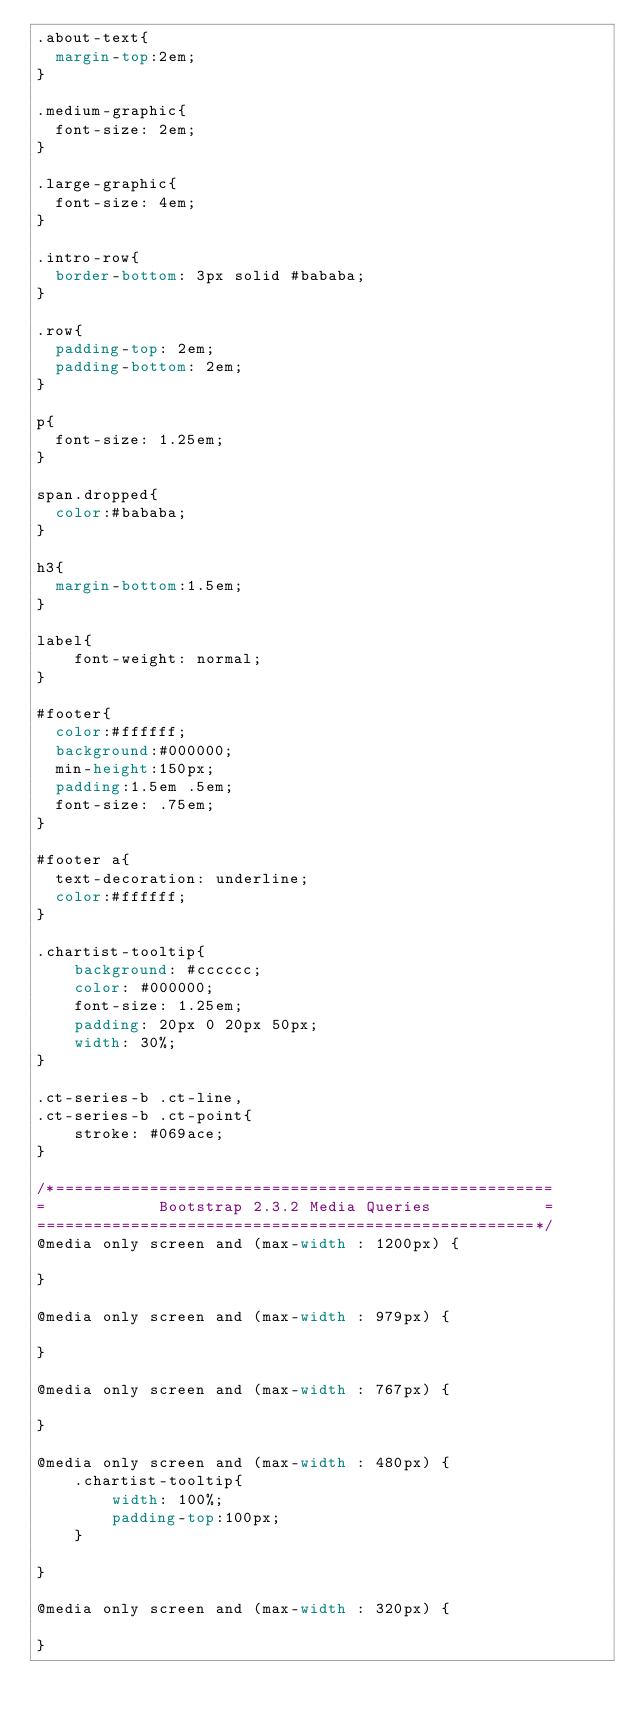<code> <loc_0><loc_0><loc_500><loc_500><_CSS_>.about-text{
  margin-top:2em;
}

.medium-graphic{
  font-size: 2em;
}

.large-graphic{
  font-size: 4em;
}

.intro-row{
  border-bottom: 3px solid #bababa;
}

.row{
  padding-top: 2em;
  padding-bottom: 2em;
}

p{
  font-size: 1.25em;
}

span.dropped{
  color:#bababa;
}

h3{
  margin-bottom:1.5em;
}

label{
    font-weight: normal;
}

#footer{
  color:#ffffff;
  background:#000000;
  min-height:150px;
  padding:1.5em .5em;
  font-size: .75em;
}

#footer a{
  text-decoration: underline;
  color:#ffffff;
}

.chartist-tooltip{
    background: #cccccc;
    color: #000000;
    font-size: 1.25em;
    padding: 20px 0 20px 50px;
    width: 30%;
}

.ct-series-b .ct-line,
.ct-series-b .ct-point{
    stroke: #069ace;
}

/*=====================================================
=            Bootstrap 2.3.2 Media Queries            =
=====================================================*/
@media only screen and (max-width : 1200px) {

}

@media only screen and (max-width : 979px) {

}

@media only screen and (max-width : 767px) {

}

@media only screen and (max-width : 480px) {
    .chartist-tooltip{
        width: 100%;
        padding-top:100px;
    }

}

@media only screen and (max-width : 320px) {

}</code> 